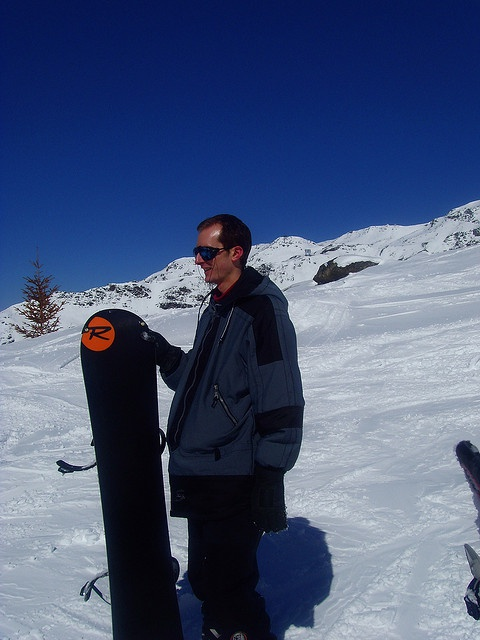Describe the objects in this image and their specific colors. I can see people in navy, black, darkgray, and maroon tones and snowboard in navy, black, brown, darkgray, and maroon tones in this image. 